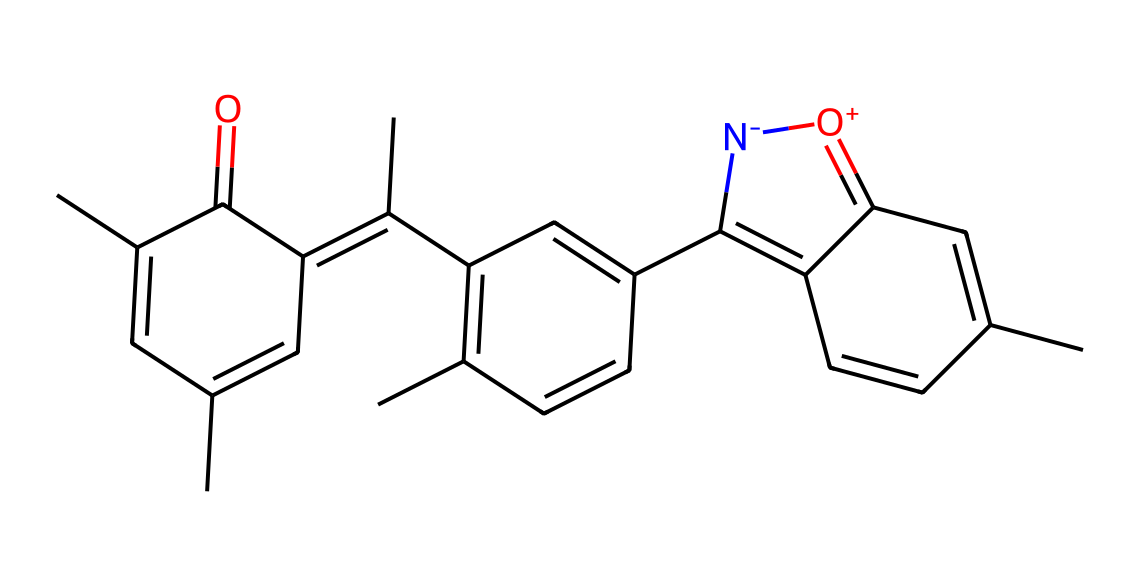What is the primary functional group present in this polymer? By analyzing the SMILES structure, we can identify the functional groups. The presence of the carbonyl group (C=O) indicates it is a ketone group.
Answer: ketone How many aromatic rings are in the given molecule? In the chemical structure, we can see multiple six-membered carbon rings, specifically three distinct aromatic rings based on the alternating double bonds.
Answer: three What is the total number of nitrogen atoms in this polymer? Upon examining the SMILES string, there is one instance of nitrogen indicated by the letter 'N', representing a single nitrogen atom.
Answer: one What is the oxidation state of the nitrogen in this polymer? The nitrogen is attached to an oxygen with a positive charge indicated by '[O+]', suggesting that the nitrogen is in a negative oxidation state, so it is negatively charged coupling with the oxygen.
Answer: negative Does this polymer contain any functional groups that could influence its photochromic properties? The presence of both a ketone and a positively charged nitrogen can contribute to its photochromic behavior by allowing electron transitions upon exposure to light.
Answer: yes 